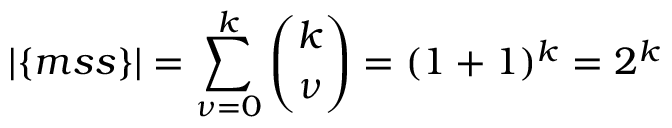Convert formula to latex. <formula><loc_0><loc_0><loc_500><loc_500>| \{ m s s \} | = \sum _ { \nu = 0 } ^ { k } { \binom { k } { \nu } } = ( 1 + 1 ) ^ { k } = 2 ^ { k }</formula> 